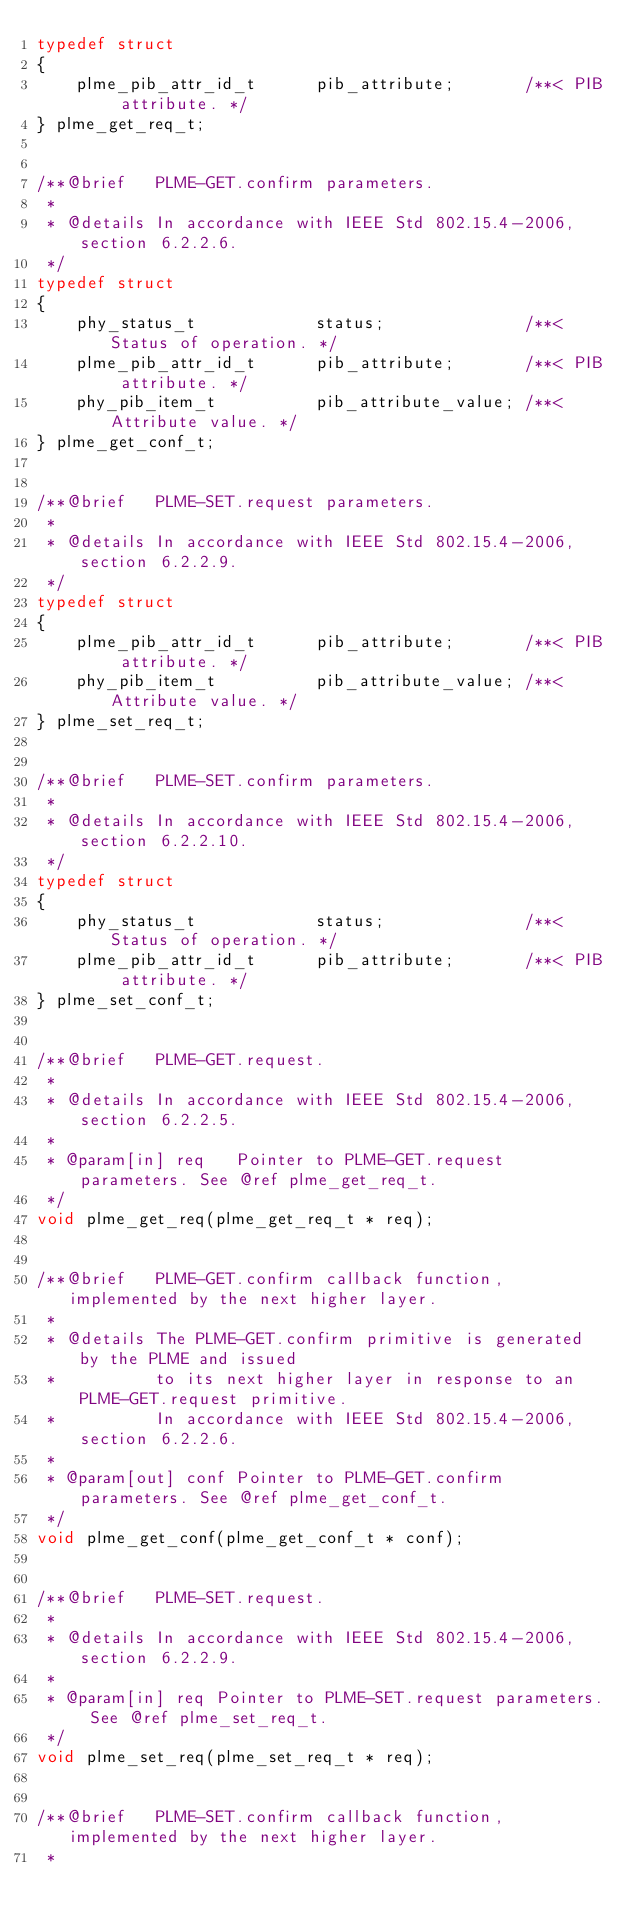Convert code to text. <code><loc_0><loc_0><loc_500><loc_500><_C_>typedef struct
{
    plme_pib_attr_id_t      pib_attribute;       /**< PIB attribute. */
} plme_get_req_t;


/**@brief   PLME-GET.confirm parameters.
 *
 * @details In accordance with IEEE Std 802.15.4-2006, section 6.2.2.6.
 */
typedef struct
{
    phy_status_t            status;              /**< Status of operation. */
    plme_pib_attr_id_t      pib_attribute;       /**< PIB attribute. */
    phy_pib_item_t          pib_attribute_value; /**< Attribute value. */
} plme_get_conf_t;


/**@brief   PLME-SET.request parameters.
 *
 * @details In accordance with IEEE Std 802.15.4-2006, section 6.2.2.9.
 */
typedef struct
{
    plme_pib_attr_id_t      pib_attribute;       /**< PIB attribute. */
    phy_pib_item_t          pib_attribute_value; /**< Attribute value. */
} plme_set_req_t;


/**@brief   PLME-SET.confirm parameters.
 *
 * @details In accordance with IEEE Std 802.15.4-2006, section 6.2.2.10.
 */
typedef struct
{
    phy_status_t            status;              /**< Status of operation. */
    plme_pib_attr_id_t      pib_attribute;       /**< PIB attribute. */
} plme_set_conf_t;


/**@brief   PLME-GET.request.
 *
 * @details In accordance with IEEE Std 802.15.4-2006, section 6.2.2.5.
 *
 * @param[in] req   Pointer to PLME-GET.request parameters. See @ref plme_get_req_t.
 */
void plme_get_req(plme_get_req_t * req);


/**@brief   PLME-GET.confirm callback function, implemented by the next higher layer.
 *
 * @details The PLME-GET.confirm primitive is generated by the PLME and issued
 *          to its next higher layer in response to an PLME-GET.request primitive.
 *          In accordance with IEEE Std 802.15.4-2006, section 6.2.2.6.
 *
 * @param[out] conf Pointer to PLME-GET.confirm parameters. See @ref plme_get_conf_t.
 */
void plme_get_conf(plme_get_conf_t * conf);


/**@brief   PLME-SET.request.
 *
 * @details In accordance with IEEE Std 802.15.4-2006, section 6.2.2.9.
 *
 * @param[in] req Pointer to PLME-SET.request parameters. See @ref plme_set_req_t.
 */
void plme_set_req(plme_set_req_t * req);


/**@brief   PLME-SET.confirm callback function, implemented by the next higher layer.
 *</code> 